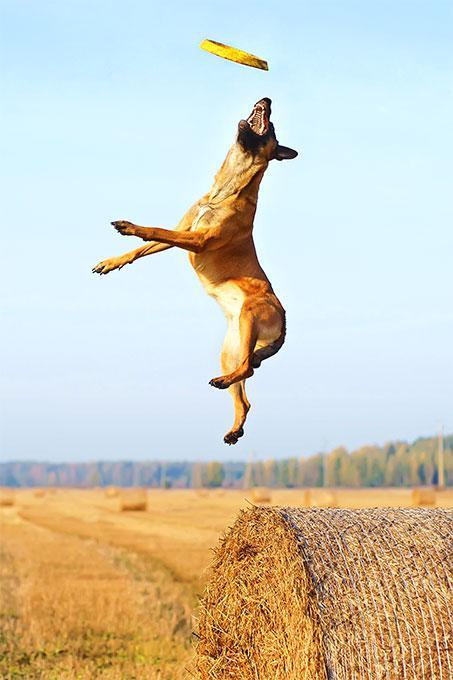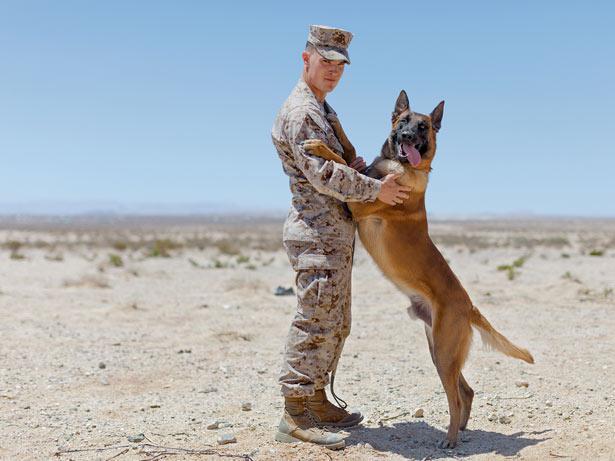The first image is the image on the left, the second image is the image on the right. Assess this claim about the two images: "One of the images shows a dog completely in the air.". Correct or not? Answer yes or no. Yes. The first image is the image on the left, the second image is the image on the right. For the images displayed, is the sentence "A dog is shown with only one soldier in one image" factually correct? Answer yes or no. Yes. 